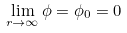Convert formula to latex. <formula><loc_0><loc_0><loc_500><loc_500>\lim _ { r \rightarrow \infty } \phi = \phi _ { 0 } = 0</formula> 